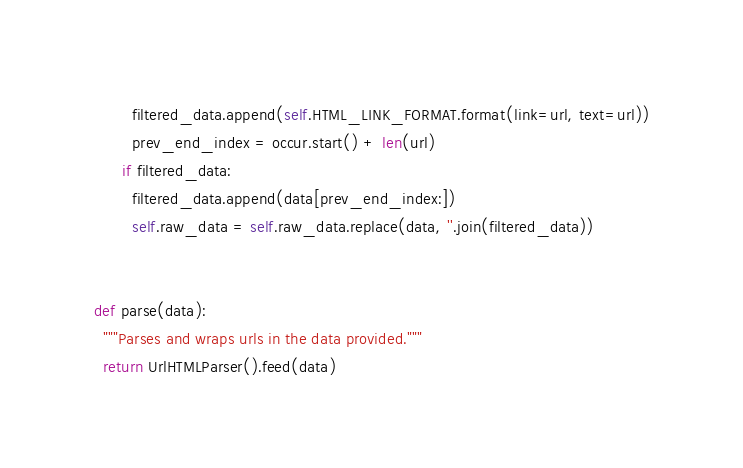Convert code to text. <code><loc_0><loc_0><loc_500><loc_500><_Python_>        filtered_data.append(self.HTML_LINK_FORMAT.format(link=url, text=url))
        prev_end_index = occur.start() + len(url)
      if filtered_data:
        filtered_data.append(data[prev_end_index:])
        self.raw_data = self.raw_data.replace(data, ''.join(filtered_data))


def parse(data):
  """Parses and wraps urls in the data provided."""
  return UrlHTMLParser().feed(data)
</code> 